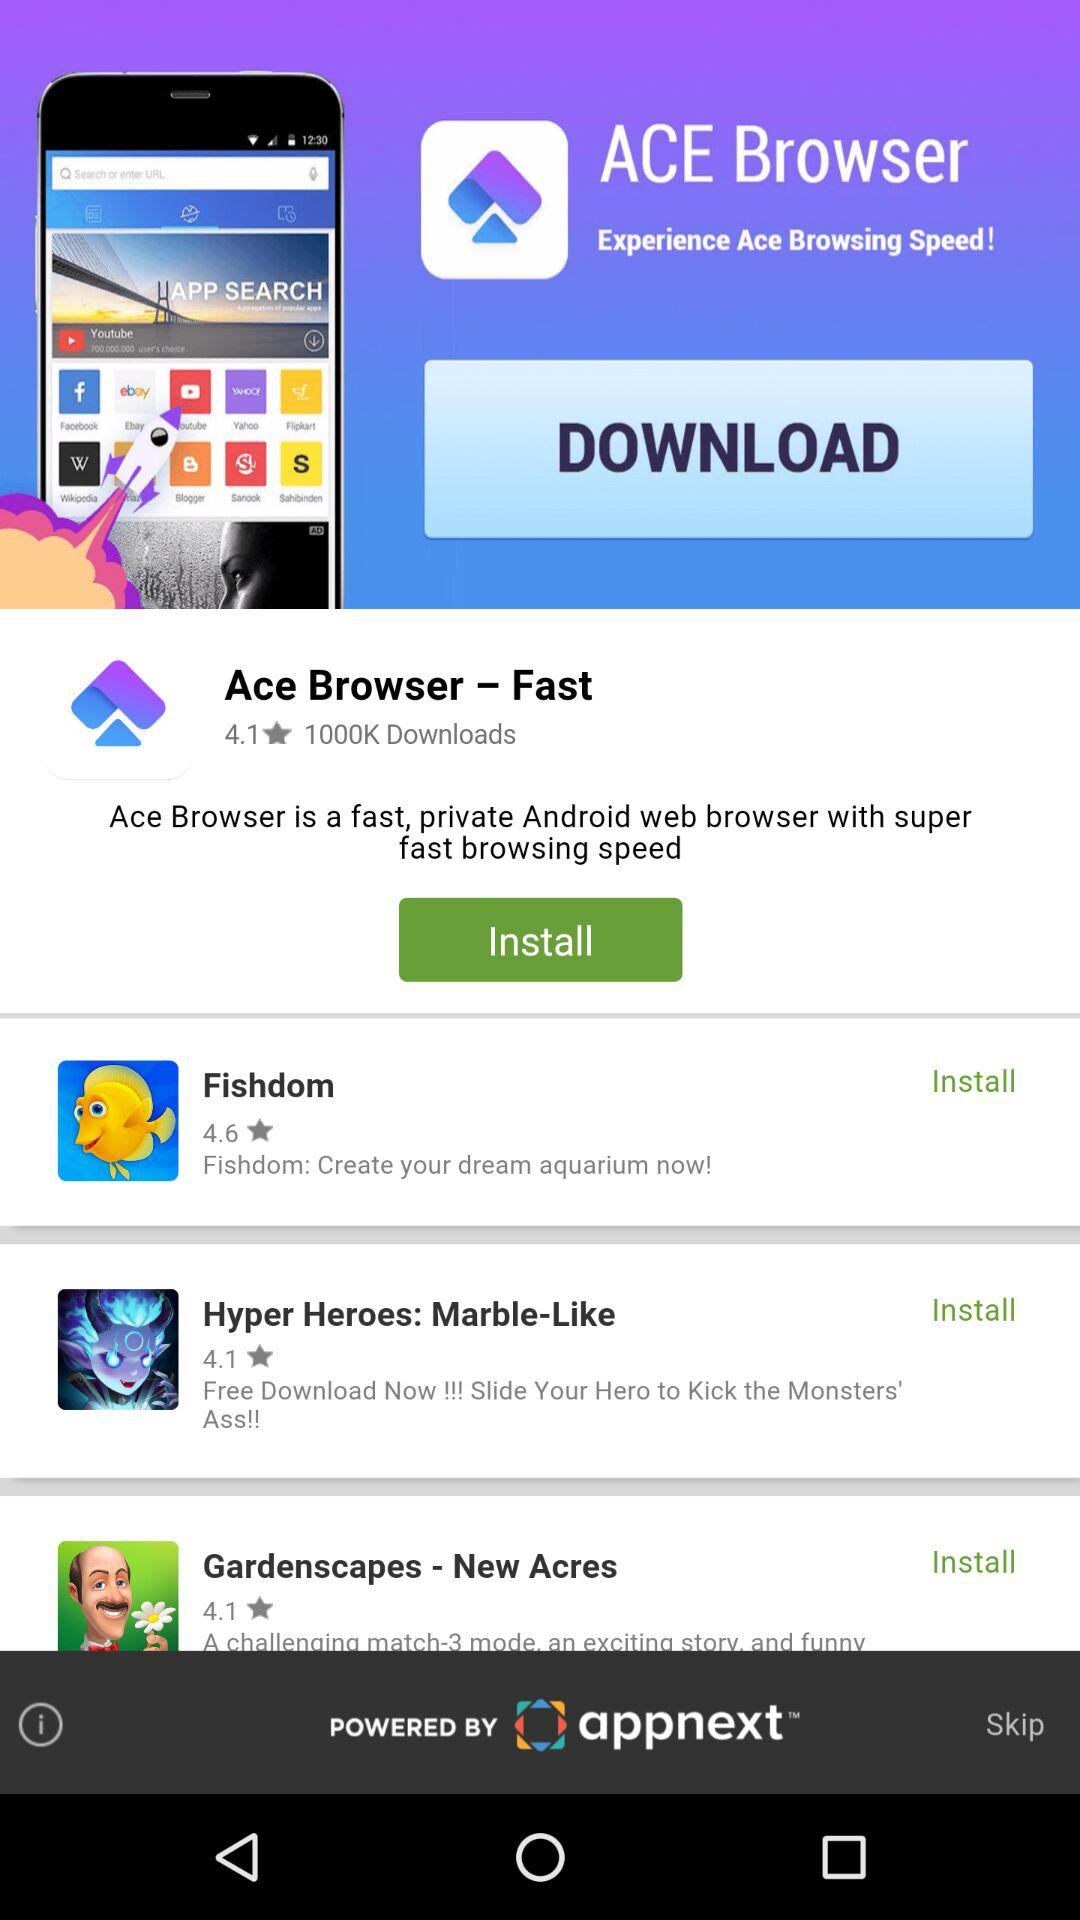How many stars did the "Ace Browser - Fast" get? It got 4.1 stars. 